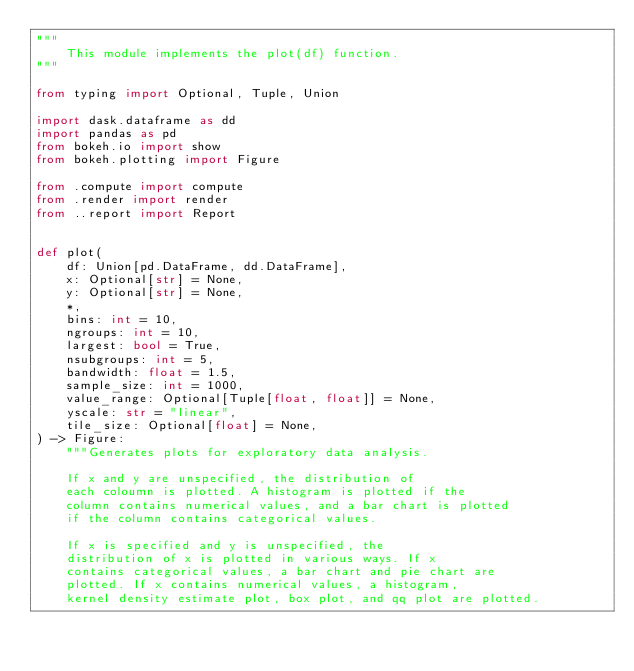<code> <loc_0><loc_0><loc_500><loc_500><_Python_>"""
    This module implements the plot(df) function.
"""

from typing import Optional, Tuple, Union

import dask.dataframe as dd
import pandas as pd
from bokeh.io import show
from bokeh.plotting import Figure

from .compute import compute
from .render import render
from ..report import Report


def plot(
    df: Union[pd.DataFrame, dd.DataFrame],
    x: Optional[str] = None,
    y: Optional[str] = None,
    *,
    bins: int = 10,
    ngroups: int = 10,
    largest: bool = True,
    nsubgroups: int = 5,
    bandwidth: float = 1.5,
    sample_size: int = 1000,
    value_range: Optional[Tuple[float, float]] = None,
    yscale: str = "linear",
    tile_size: Optional[float] = None,
) -> Figure:
    """Generates plots for exploratory data analysis.

    If x and y are unspecified, the distribution of
    each coloumn is plotted. A histogram is plotted if the
    column contains numerical values, and a bar chart is plotted
    if the column contains categorical values.

    If x is specified and y is unspecified, the
    distribution of x is plotted in various ways. If x
    contains categorical values, a bar chart and pie chart are
    plotted. If x contains numerical values, a histogram,
    kernel density estimate plot, box plot, and qq plot are plotted.
</code> 